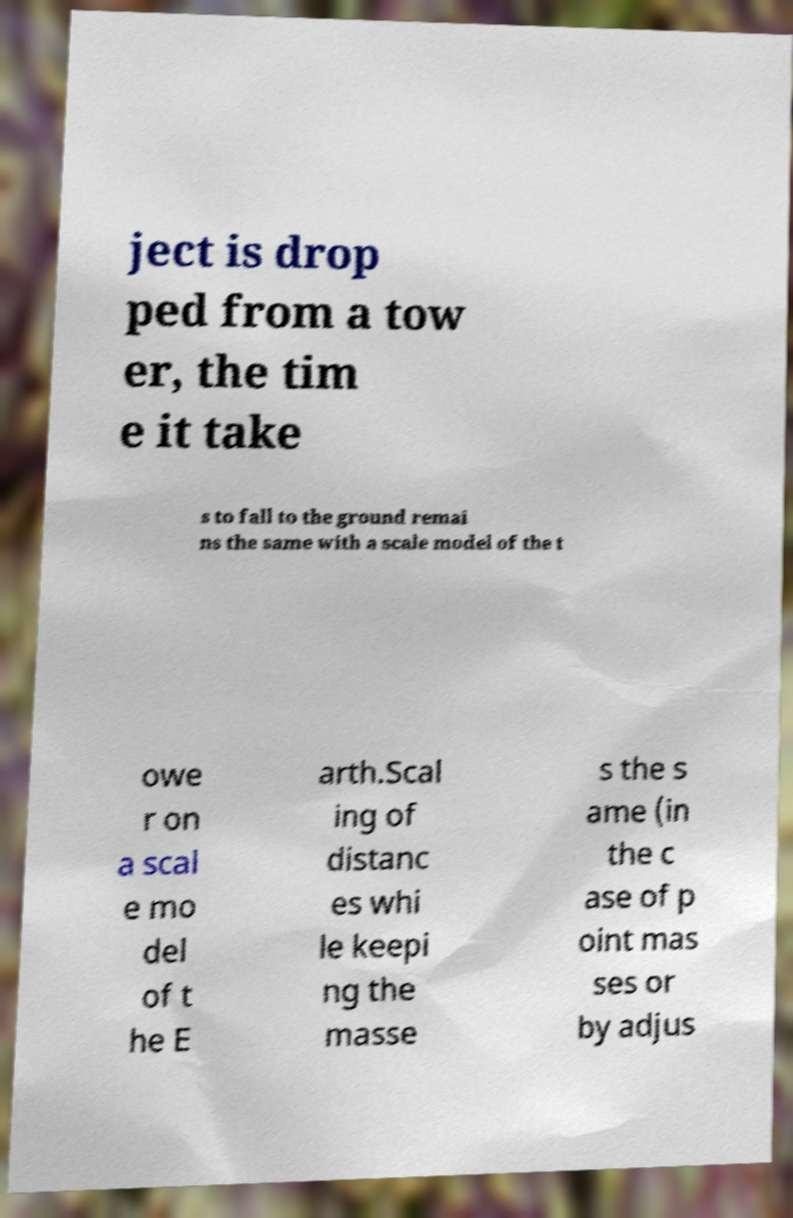Could you extract and type out the text from this image? ject is drop ped from a tow er, the tim e it take s to fall to the ground remai ns the same with a scale model of the t owe r on a scal e mo del of t he E arth.Scal ing of distanc es whi le keepi ng the masse s the s ame (in the c ase of p oint mas ses or by adjus 